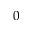<formula> <loc_0><loc_0><loc_500><loc_500>0</formula> 